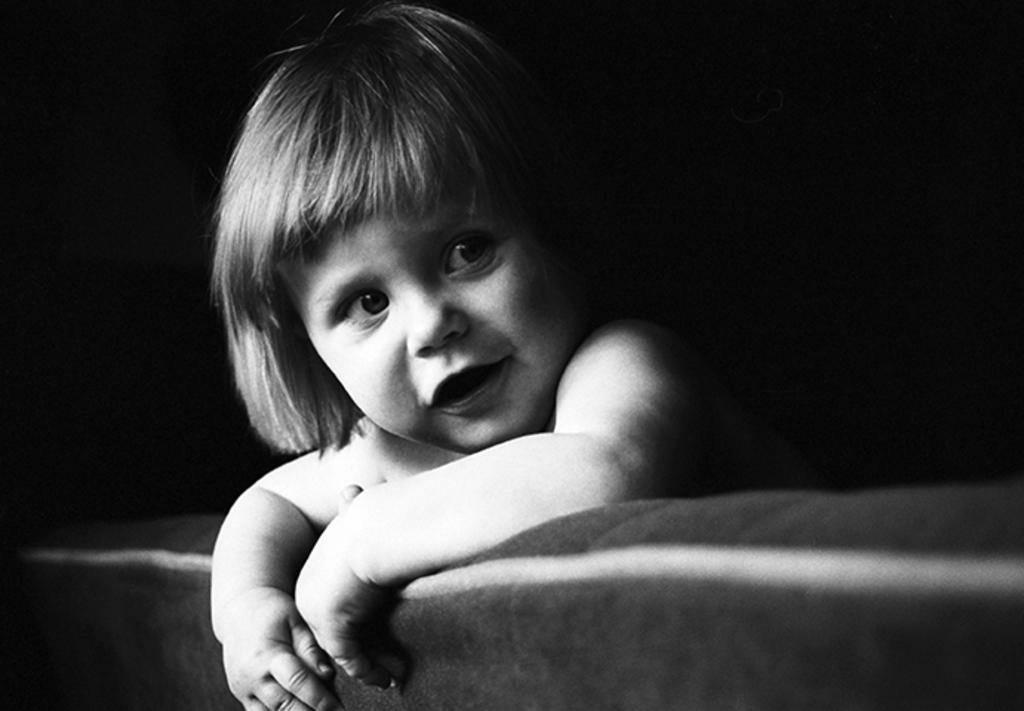In one or two sentences, can you explain what this image depicts? I see this is a black and white image and I see a baby over here. 